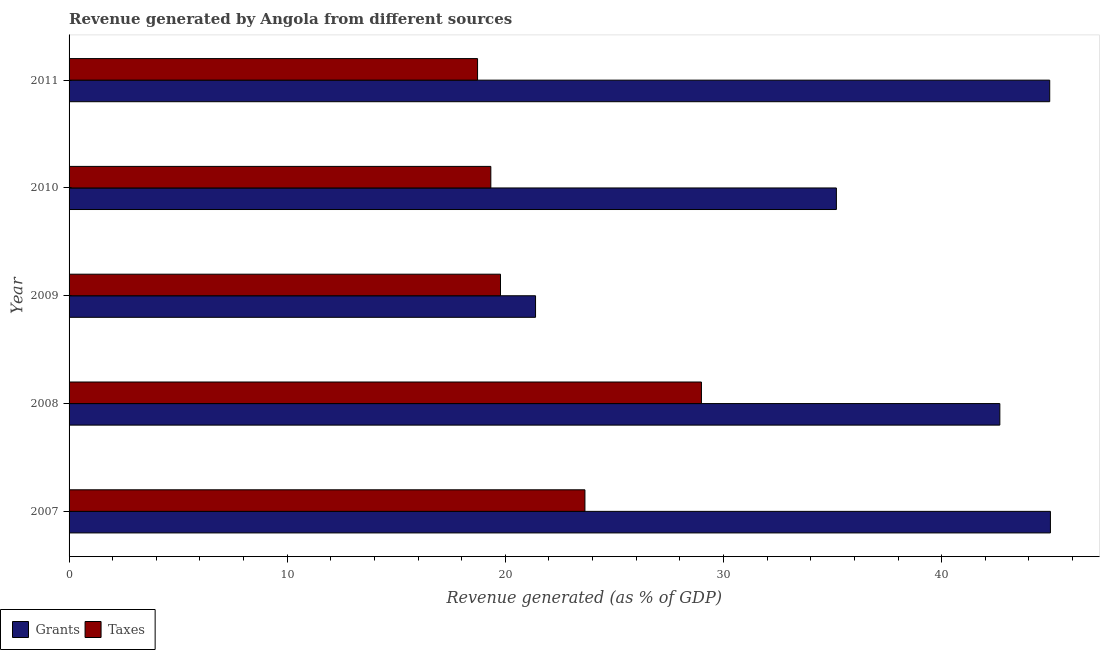How many bars are there on the 2nd tick from the top?
Your answer should be compact. 2. What is the label of the 1st group of bars from the top?
Your response must be concise. 2011. In how many cases, is the number of bars for a given year not equal to the number of legend labels?
Your answer should be very brief. 0. What is the revenue generated by grants in 2008?
Provide a short and direct response. 42.67. Across all years, what is the maximum revenue generated by taxes?
Provide a short and direct response. 28.99. Across all years, what is the minimum revenue generated by grants?
Ensure brevity in your answer.  21.38. In which year was the revenue generated by grants maximum?
Your answer should be compact. 2007. What is the total revenue generated by grants in the graph?
Your answer should be compact. 189.17. What is the difference between the revenue generated by grants in 2007 and that in 2008?
Your response must be concise. 2.32. What is the difference between the revenue generated by grants in 2008 and the revenue generated by taxes in 2007?
Provide a short and direct response. 19.02. What is the average revenue generated by grants per year?
Provide a succinct answer. 37.83. In the year 2008, what is the difference between the revenue generated by taxes and revenue generated by grants?
Offer a terse response. -13.68. In how many years, is the revenue generated by taxes greater than 24 %?
Make the answer very short. 1. Is the difference between the revenue generated by grants in 2007 and 2010 greater than the difference between the revenue generated by taxes in 2007 and 2010?
Give a very brief answer. Yes. What is the difference between the highest and the second highest revenue generated by taxes?
Provide a short and direct response. 5.34. What is the difference between the highest and the lowest revenue generated by grants?
Your answer should be very brief. 23.6. In how many years, is the revenue generated by taxes greater than the average revenue generated by taxes taken over all years?
Ensure brevity in your answer.  2. What does the 1st bar from the top in 2007 represents?
Ensure brevity in your answer.  Taxes. What does the 1st bar from the bottom in 2011 represents?
Make the answer very short. Grants. Are all the bars in the graph horizontal?
Offer a terse response. Yes. How many years are there in the graph?
Provide a succinct answer. 5. Are the values on the major ticks of X-axis written in scientific E-notation?
Your response must be concise. No. Does the graph contain any zero values?
Your answer should be compact. No. How many legend labels are there?
Keep it short and to the point. 2. How are the legend labels stacked?
Offer a terse response. Horizontal. What is the title of the graph?
Offer a terse response. Revenue generated by Angola from different sources. What is the label or title of the X-axis?
Your answer should be compact. Revenue generated (as % of GDP). What is the Revenue generated (as % of GDP) in Grants in 2007?
Ensure brevity in your answer.  44.99. What is the Revenue generated (as % of GDP) in Taxes in 2007?
Your answer should be very brief. 23.65. What is the Revenue generated (as % of GDP) in Grants in 2008?
Make the answer very short. 42.67. What is the Revenue generated (as % of GDP) in Taxes in 2008?
Offer a terse response. 28.99. What is the Revenue generated (as % of GDP) in Grants in 2009?
Your answer should be very brief. 21.38. What is the Revenue generated (as % of GDP) in Taxes in 2009?
Make the answer very short. 19.78. What is the Revenue generated (as % of GDP) in Grants in 2010?
Your answer should be compact. 35.17. What is the Revenue generated (as % of GDP) of Taxes in 2010?
Your response must be concise. 19.33. What is the Revenue generated (as % of GDP) in Grants in 2011?
Offer a terse response. 44.95. What is the Revenue generated (as % of GDP) in Taxes in 2011?
Make the answer very short. 18.73. Across all years, what is the maximum Revenue generated (as % of GDP) in Grants?
Your response must be concise. 44.99. Across all years, what is the maximum Revenue generated (as % of GDP) in Taxes?
Your answer should be compact. 28.99. Across all years, what is the minimum Revenue generated (as % of GDP) of Grants?
Keep it short and to the point. 21.38. Across all years, what is the minimum Revenue generated (as % of GDP) of Taxes?
Give a very brief answer. 18.73. What is the total Revenue generated (as % of GDP) in Grants in the graph?
Your response must be concise. 189.17. What is the total Revenue generated (as % of GDP) of Taxes in the graph?
Keep it short and to the point. 110.47. What is the difference between the Revenue generated (as % of GDP) in Grants in 2007 and that in 2008?
Your answer should be very brief. 2.32. What is the difference between the Revenue generated (as % of GDP) in Taxes in 2007 and that in 2008?
Offer a very short reply. -5.34. What is the difference between the Revenue generated (as % of GDP) of Grants in 2007 and that in 2009?
Provide a short and direct response. 23.6. What is the difference between the Revenue generated (as % of GDP) of Taxes in 2007 and that in 2009?
Give a very brief answer. 3.87. What is the difference between the Revenue generated (as % of GDP) in Grants in 2007 and that in 2010?
Ensure brevity in your answer.  9.81. What is the difference between the Revenue generated (as % of GDP) in Taxes in 2007 and that in 2010?
Your response must be concise. 4.31. What is the difference between the Revenue generated (as % of GDP) of Grants in 2007 and that in 2011?
Your answer should be compact. 0.03. What is the difference between the Revenue generated (as % of GDP) in Taxes in 2007 and that in 2011?
Your answer should be very brief. 4.92. What is the difference between the Revenue generated (as % of GDP) of Grants in 2008 and that in 2009?
Offer a terse response. 21.28. What is the difference between the Revenue generated (as % of GDP) in Taxes in 2008 and that in 2009?
Offer a terse response. 9.21. What is the difference between the Revenue generated (as % of GDP) of Grants in 2008 and that in 2010?
Give a very brief answer. 7.49. What is the difference between the Revenue generated (as % of GDP) of Taxes in 2008 and that in 2010?
Your answer should be compact. 9.65. What is the difference between the Revenue generated (as % of GDP) of Grants in 2008 and that in 2011?
Provide a succinct answer. -2.29. What is the difference between the Revenue generated (as % of GDP) of Taxes in 2008 and that in 2011?
Give a very brief answer. 10.26. What is the difference between the Revenue generated (as % of GDP) of Grants in 2009 and that in 2010?
Provide a short and direct response. -13.79. What is the difference between the Revenue generated (as % of GDP) in Taxes in 2009 and that in 2010?
Ensure brevity in your answer.  0.44. What is the difference between the Revenue generated (as % of GDP) of Grants in 2009 and that in 2011?
Your answer should be compact. -23.57. What is the difference between the Revenue generated (as % of GDP) in Taxes in 2009 and that in 2011?
Give a very brief answer. 1.05. What is the difference between the Revenue generated (as % of GDP) in Grants in 2010 and that in 2011?
Ensure brevity in your answer.  -9.78. What is the difference between the Revenue generated (as % of GDP) in Taxes in 2010 and that in 2011?
Make the answer very short. 0.61. What is the difference between the Revenue generated (as % of GDP) in Grants in 2007 and the Revenue generated (as % of GDP) in Taxes in 2008?
Offer a very short reply. 16. What is the difference between the Revenue generated (as % of GDP) in Grants in 2007 and the Revenue generated (as % of GDP) in Taxes in 2009?
Provide a short and direct response. 25.21. What is the difference between the Revenue generated (as % of GDP) of Grants in 2007 and the Revenue generated (as % of GDP) of Taxes in 2010?
Provide a short and direct response. 25.65. What is the difference between the Revenue generated (as % of GDP) of Grants in 2007 and the Revenue generated (as % of GDP) of Taxes in 2011?
Offer a terse response. 26.26. What is the difference between the Revenue generated (as % of GDP) of Grants in 2008 and the Revenue generated (as % of GDP) of Taxes in 2009?
Provide a short and direct response. 22.89. What is the difference between the Revenue generated (as % of GDP) in Grants in 2008 and the Revenue generated (as % of GDP) in Taxes in 2010?
Keep it short and to the point. 23.33. What is the difference between the Revenue generated (as % of GDP) in Grants in 2008 and the Revenue generated (as % of GDP) in Taxes in 2011?
Provide a succinct answer. 23.94. What is the difference between the Revenue generated (as % of GDP) of Grants in 2009 and the Revenue generated (as % of GDP) of Taxes in 2010?
Give a very brief answer. 2.05. What is the difference between the Revenue generated (as % of GDP) of Grants in 2009 and the Revenue generated (as % of GDP) of Taxes in 2011?
Your response must be concise. 2.66. What is the difference between the Revenue generated (as % of GDP) of Grants in 2010 and the Revenue generated (as % of GDP) of Taxes in 2011?
Offer a terse response. 16.45. What is the average Revenue generated (as % of GDP) of Grants per year?
Provide a short and direct response. 37.83. What is the average Revenue generated (as % of GDP) of Taxes per year?
Your answer should be compact. 22.09. In the year 2007, what is the difference between the Revenue generated (as % of GDP) in Grants and Revenue generated (as % of GDP) in Taxes?
Your answer should be compact. 21.34. In the year 2008, what is the difference between the Revenue generated (as % of GDP) of Grants and Revenue generated (as % of GDP) of Taxes?
Keep it short and to the point. 13.68. In the year 2009, what is the difference between the Revenue generated (as % of GDP) of Grants and Revenue generated (as % of GDP) of Taxes?
Your response must be concise. 1.61. In the year 2010, what is the difference between the Revenue generated (as % of GDP) in Grants and Revenue generated (as % of GDP) in Taxes?
Provide a short and direct response. 15.84. In the year 2011, what is the difference between the Revenue generated (as % of GDP) in Grants and Revenue generated (as % of GDP) in Taxes?
Your answer should be very brief. 26.23. What is the ratio of the Revenue generated (as % of GDP) of Grants in 2007 to that in 2008?
Offer a very short reply. 1.05. What is the ratio of the Revenue generated (as % of GDP) in Taxes in 2007 to that in 2008?
Your answer should be compact. 0.82. What is the ratio of the Revenue generated (as % of GDP) of Grants in 2007 to that in 2009?
Make the answer very short. 2.1. What is the ratio of the Revenue generated (as % of GDP) of Taxes in 2007 to that in 2009?
Make the answer very short. 1.2. What is the ratio of the Revenue generated (as % of GDP) in Grants in 2007 to that in 2010?
Give a very brief answer. 1.28. What is the ratio of the Revenue generated (as % of GDP) in Taxes in 2007 to that in 2010?
Offer a very short reply. 1.22. What is the ratio of the Revenue generated (as % of GDP) in Grants in 2007 to that in 2011?
Your response must be concise. 1. What is the ratio of the Revenue generated (as % of GDP) of Taxes in 2007 to that in 2011?
Provide a succinct answer. 1.26. What is the ratio of the Revenue generated (as % of GDP) in Grants in 2008 to that in 2009?
Make the answer very short. 2. What is the ratio of the Revenue generated (as % of GDP) in Taxes in 2008 to that in 2009?
Provide a succinct answer. 1.47. What is the ratio of the Revenue generated (as % of GDP) of Grants in 2008 to that in 2010?
Make the answer very short. 1.21. What is the ratio of the Revenue generated (as % of GDP) in Taxes in 2008 to that in 2010?
Provide a short and direct response. 1.5. What is the ratio of the Revenue generated (as % of GDP) of Grants in 2008 to that in 2011?
Give a very brief answer. 0.95. What is the ratio of the Revenue generated (as % of GDP) of Taxes in 2008 to that in 2011?
Your response must be concise. 1.55. What is the ratio of the Revenue generated (as % of GDP) in Grants in 2009 to that in 2010?
Your response must be concise. 0.61. What is the ratio of the Revenue generated (as % of GDP) in Grants in 2009 to that in 2011?
Provide a short and direct response. 0.48. What is the ratio of the Revenue generated (as % of GDP) in Taxes in 2009 to that in 2011?
Your response must be concise. 1.06. What is the ratio of the Revenue generated (as % of GDP) of Grants in 2010 to that in 2011?
Ensure brevity in your answer.  0.78. What is the ratio of the Revenue generated (as % of GDP) in Taxes in 2010 to that in 2011?
Offer a very short reply. 1.03. What is the difference between the highest and the second highest Revenue generated (as % of GDP) of Grants?
Offer a terse response. 0.03. What is the difference between the highest and the second highest Revenue generated (as % of GDP) of Taxes?
Offer a terse response. 5.34. What is the difference between the highest and the lowest Revenue generated (as % of GDP) in Grants?
Give a very brief answer. 23.6. What is the difference between the highest and the lowest Revenue generated (as % of GDP) in Taxes?
Keep it short and to the point. 10.26. 